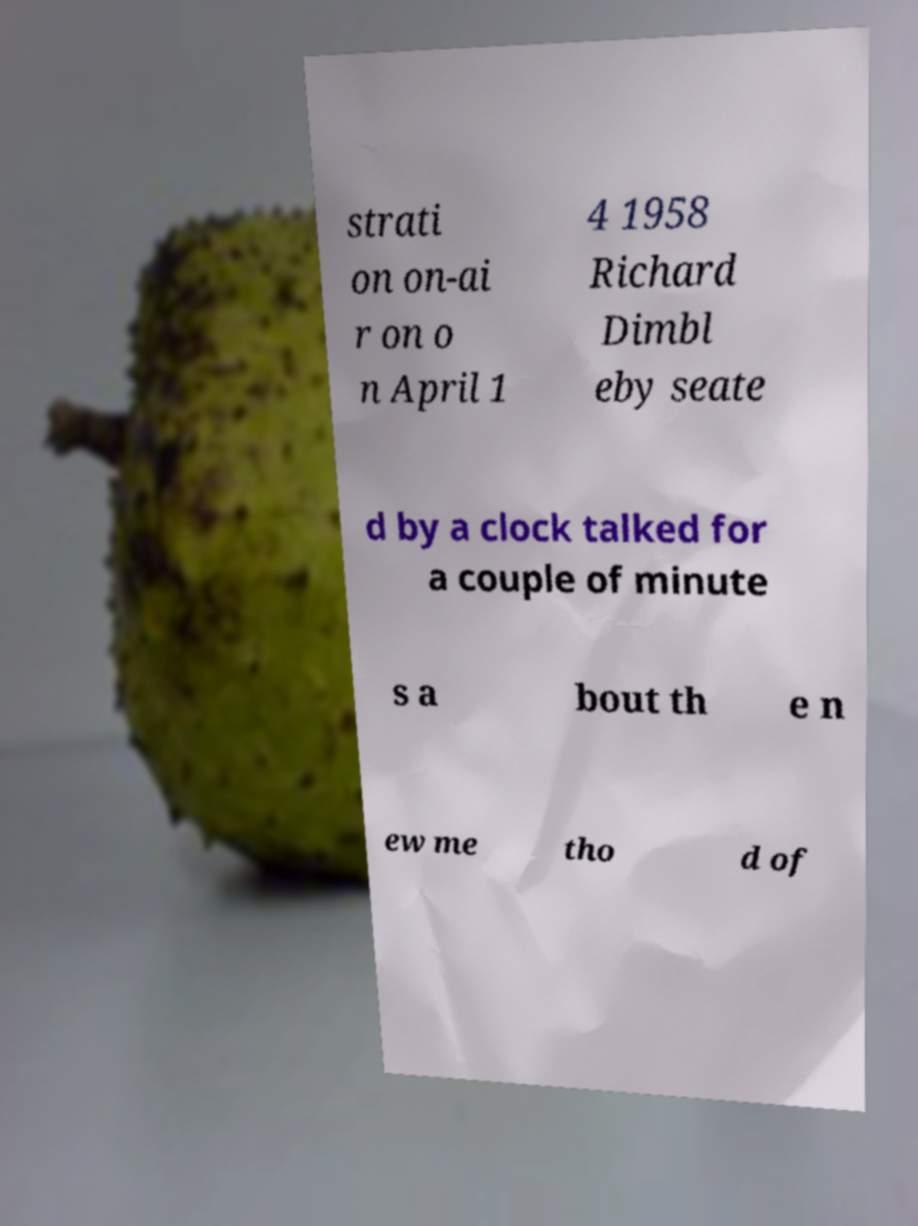For documentation purposes, I need the text within this image transcribed. Could you provide that? strati on on-ai r on o n April 1 4 1958 Richard Dimbl eby seate d by a clock talked for a couple of minute s a bout th e n ew me tho d of 